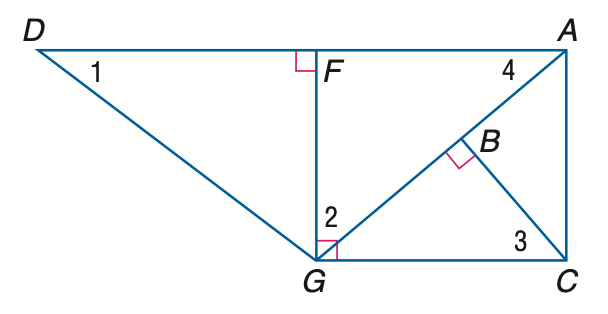Question: Find the measure of \angle 3 if m \angle D G F = 53 and m \angle A G C = 40.
Choices:
A. 40
B. 47
C. 50
D. 53
Answer with the letter. Answer: C Question: Find the measure of \angle 1 if m \angle D G F = 53 and m \angle A G C = 40.
Choices:
A. 30
B. 37
C. 40
D. 50
Answer with the letter. Answer: B Question: Find the measure of \angle 2 if m \angle D G F = 53 and m \angle A G C = 40.
Choices:
A. 40
B. 43
C. 50
D. 53
Answer with the letter. Answer: C 